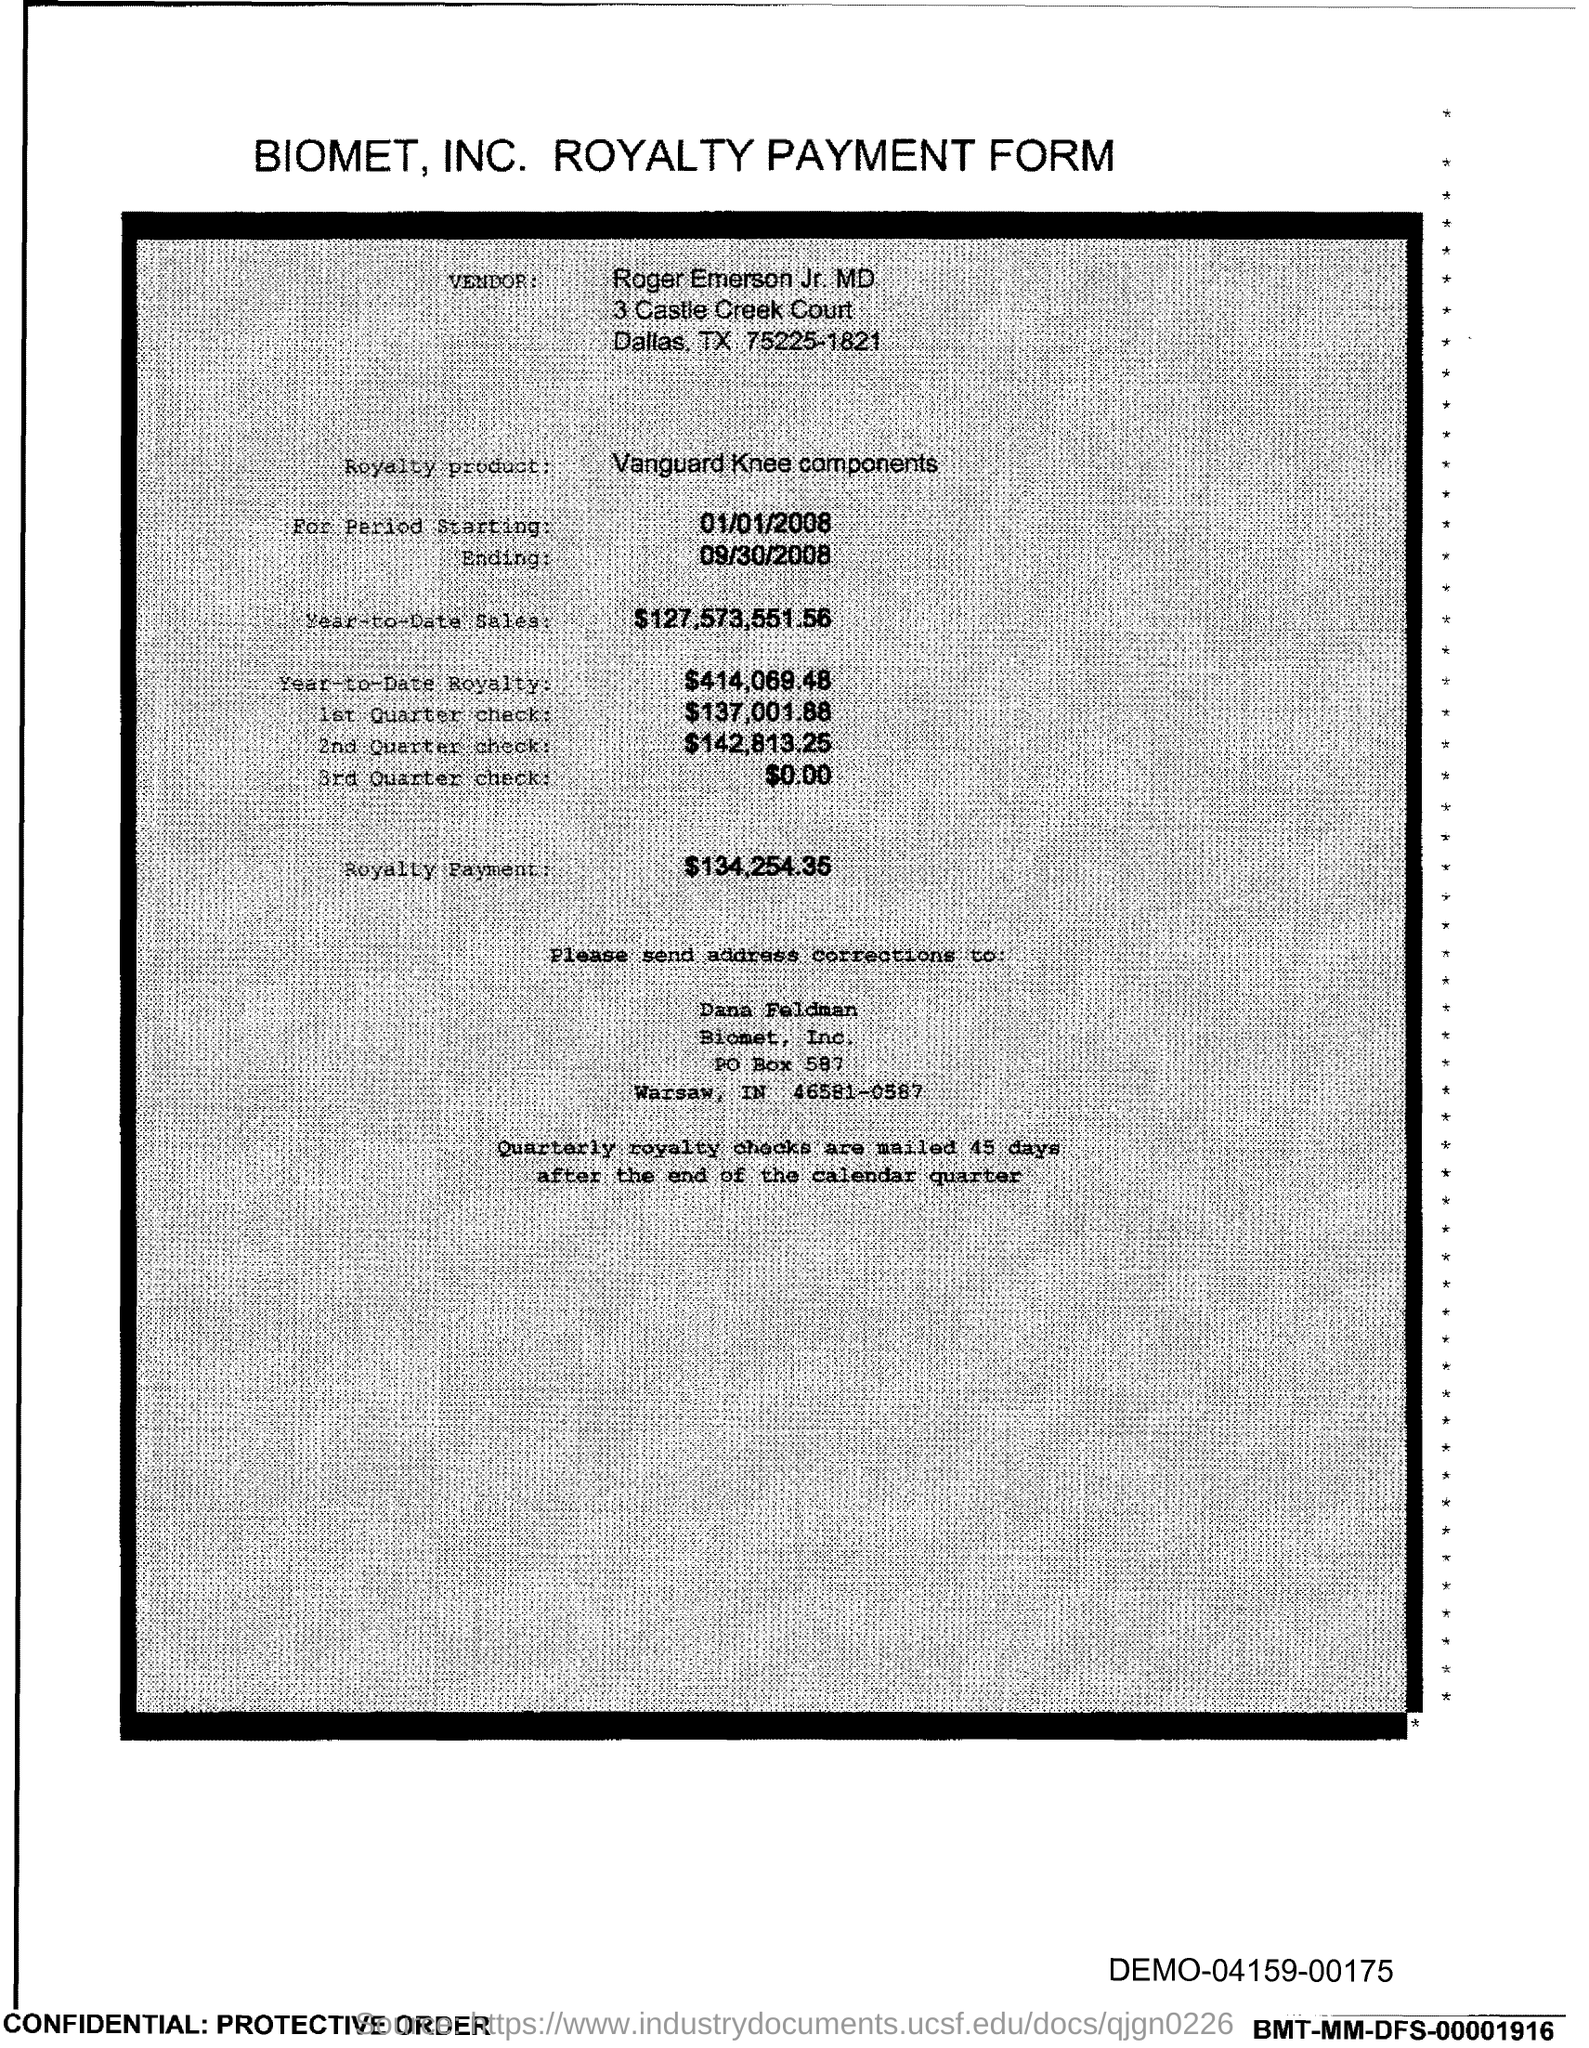Give some essential details in this illustration. The document provides a PO Box number of 587. 